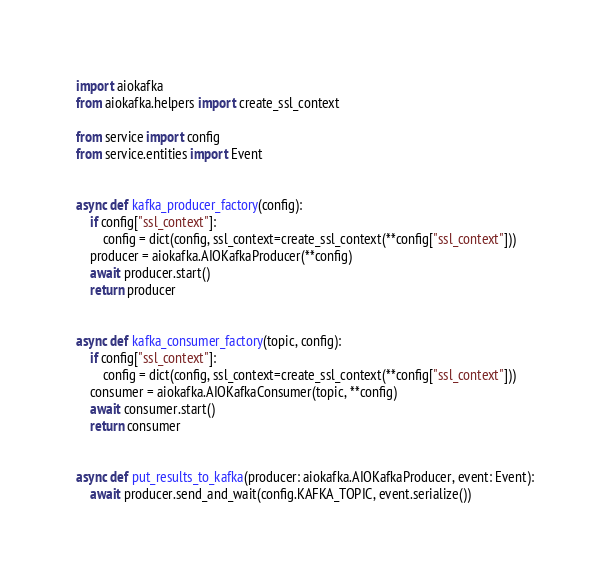<code> <loc_0><loc_0><loc_500><loc_500><_Python_>import aiokafka
from aiokafka.helpers import create_ssl_context

from service import config
from service.entities import Event


async def kafka_producer_factory(config):
    if config["ssl_context"]:
        config = dict(config, ssl_context=create_ssl_context(**config["ssl_context"]))
    producer = aiokafka.AIOKafkaProducer(**config)
    await producer.start()
    return producer


async def kafka_consumer_factory(topic, config):
    if config["ssl_context"]:
        config = dict(config, ssl_context=create_ssl_context(**config["ssl_context"]))
    consumer = aiokafka.AIOKafkaConsumer(topic, **config)
    await consumer.start()
    return consumer


async def put_results_to_kafka(producer: aiokafka.AIOKafkaProducer, event: Event):
    await producer.send_and_wait(config.KAFKA_TOPIC, event.serialize())
</code> 